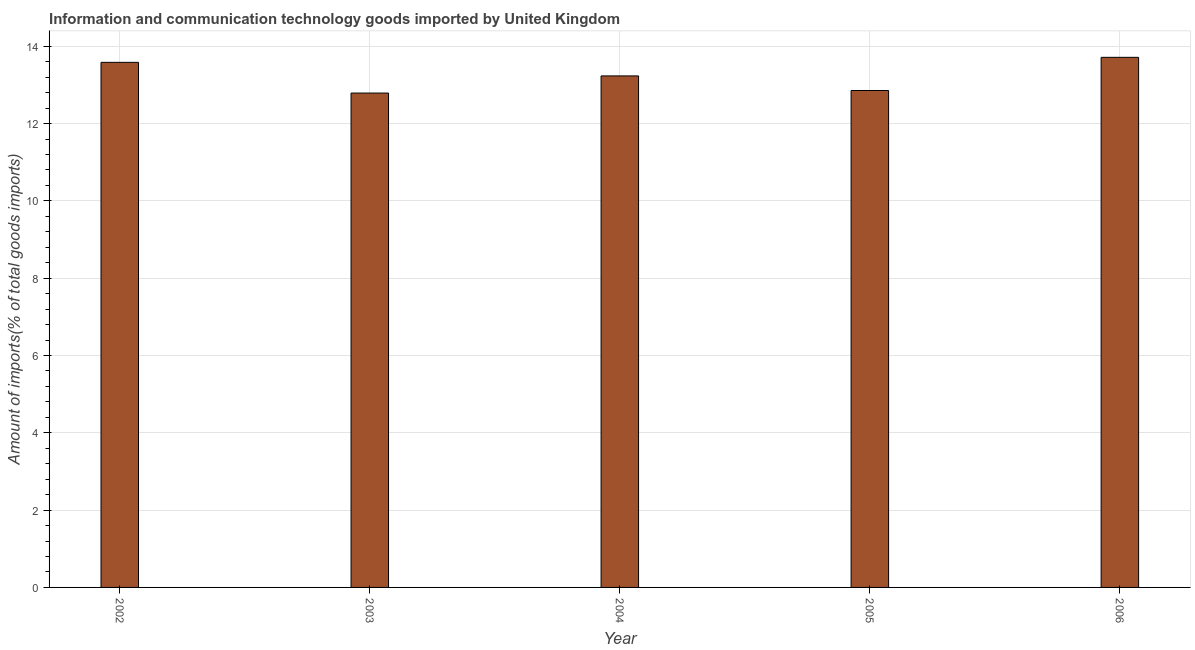Does the graph contain grids?
Give a very brief answer. Yes. What is the title of the graph?
Keep it short and to the point. Information and communication technology goods imported by United Kingdom. What is the label or title of the Y-axis?
Offer a very short reply. Amount of imports(% of total goods imports). What is the amount of ict goods imports in 2002?
Your answer should be compact. 13.58. Across all years, what is the maximum amount of ict goods imports?
Your answer should be very brief. 13.71. Across all years, what is the minimum amount of ict goods imports?
Provide a succinct answer. 12.79. In which year was the amount of ict goods imports maximum?
Ensure brevity in your answer.  2006. What is the sum of the amount of ict goods imports?
Offer a terse response. 66.17. What is the difference between the amount of ict goods imports in 2002 and 2005?
Give a very brief answer. 0.73. What is the average amount of ict goods imports per year?
Give a very brief answer. 13.23. What is the median amount of ict goods imports?
Give a very brief answer. 13.23. Is the difference between the amount of ict goods imports in 2003 and 2005 greater than the difference between any two years?
Your answer should be very brief. No. What is the difference between the highest and the second highest amount of ict goods imports?
Your answer should be very brief. 0.13. Is the sum of the amount of ict goods imports in 2004 and 2005 greater than the maximum amount of ict goods imports across all years?
Provide a succinct answer. Yes. Are all the bars in the graph horizontal?
Make the answer very short. No. What is the difference between two consecutive major ticks on the Y-axis?
Ensure brevity in your answer.  2. What is the Amount of imports(% of total goods imports) in 2002?
Give a very brief answer. 13.58. What is the Amount of imports(% of total goods imports) of 2003?
Ensure brevity in your answer.  12.79. What is the Amount of imports(% of total goods imports) of 2004?
Your answer should be compact. 13.23. What is the Amount of imports(% of total goods imports) in 2005?
Ensure brevity in your answer.  12.86. What is the Amount of imports(% of total goods imports) of 2006?
Your response must be concise. 13.71. What is the difference between the Amount of imports(% of total goods imports) in 2002 and 2003?
Make the answer very short. 0.79. What is the difference between the Amount of imports(% of total goods imports) in 2002 and 2004?
Keep it short and to the point. 0.35. What is the difference between the Amount of imports(% of total goods imports) in 2002 and 2005?
Ensure brevity in your answer.  0.73. What is the difference between the Amount of imports(% of total goods imports) in 2002 and 2006?
Offer a terse response. -0.13. What is the difference between the Amount of imports(% of total goods imports) in 2003 and 2004?
Provide a short and direct response. -0.44. What is the difference between the Amount of imports(% of total goods imports) in 2003 and 2005?
Your response must be concise. -0.07. What is the difference between the Amount of imports(% of total goods imports) in 2003 and 2006?
Provide a succinct answer. -0.92. What is the difference between the Amount of imports(% of total goods imports) in 2004 and 2005?
Offer a very short reply. 0.38. What is the difference between the Amount of imports(% of total goods imports) in 2004 and 2006?
Provide a succinct answer. -0.48. What is the difference between the Amount of imports(% of total goods imports) in 2005 and 2006?
Keep it short and to the point. -0.86. What is the ratio of the Amount of imports(% of total goods imports) in 2002 to that in 2003?
Give a very brief answer. 1.06. What is the ratio of the Amount of imports(% of total goods imports) in 2002 to that in 2005?
Your answer should be compact. 1.06. What is the ratio of the Amount of imports(% of total goods imports) in 2002 to that in 2006?
Keep it short and to the point. 0.99. What is the ratio of the Amount of imports(% of total goods imports) in 2003 to that in 2004?
Provide a succinct answer. 0.97. What is the ratio of the Amount of imports(% of total goods imports) in 2003 to that in 2005?
Provide a short and direct response. 0.99. What is the ratio of the Amount of imports(% of total goods imports) in 2003 to that in 2006?
Give a very brief answer. 0.93. What is the ratio of the Amount of imports(% of total goods imports) in 2004 to that in 2005?
Provide a short and direct response. 1.03. What is the ratio of the Amount of imports(% of total goods imports) in 2005 to that in 2006?
Your answer should be compact. 0.94. 